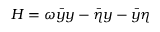Convert formula to latex. <formula><loc_0><loc_0><loc_500><loc_500>H = \omega \bar { y } y - \bar { \eta } y - \bar { y } \eta</formula> 